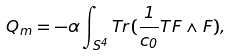Convert formula to latex. <formula><loc_0><loc_0><loc_500><loc_500>Q _ { m } = - \alpha \int _ { S ^ { 4 } } T r ( \frac { 1 } { c _ { 0 } } T F \wedge F ) ,</formula> 